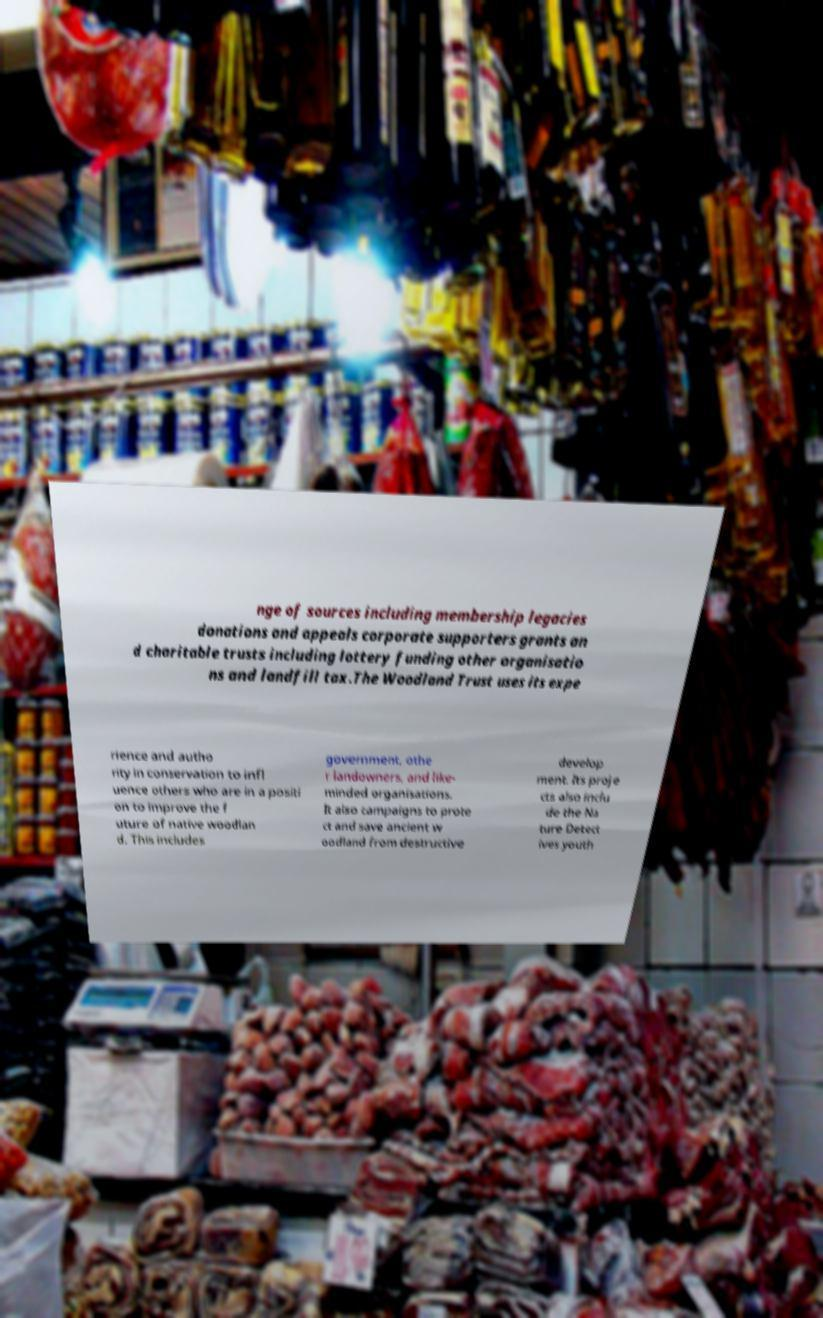Can you accurately transcribe the text from the provided image for me? nge of sources including membership legacies donations and appeals corporate supporters grants an d charitable trusts including lottery funding other organisatio ns and landfill tax.The Woodland Trust uses its expe rience and autho rity in conservation to infl uence others who are in a positi on to improve the f uture of native woodlan d. This includes government, othe r landowners, and like- minded organisations. It also campaigns to prote ct and save ancient w oodland from destructive develop ment. Its proje cts also inclu de the Na ture Detect ives youth 